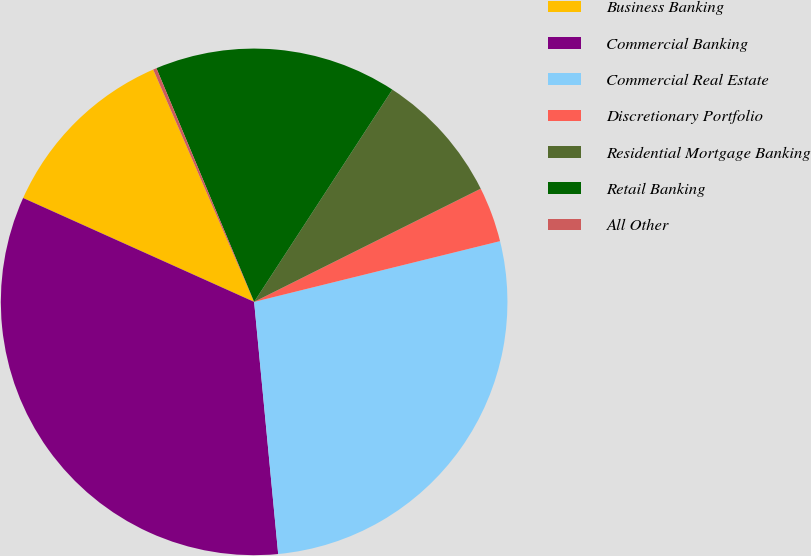Convert chart to OTSL. <chart><loc_0><loc_0><loc_500><loc_500><pie_chart><fcel>Business Banking<fcel>Commercial Banking<fcel>Commercial Real Estate<fcel>Discretionary Portfolio<fcel>Residential Mortgage Banking<fcel>Retail Banking<fcel>All Other<nl><fcel>11.75%<fcel>33.24%<fcel>27.34%<fcel>3.52%<fcel>8.44%<fcel>15.49%<fcel>0.22%<nl></chart> 